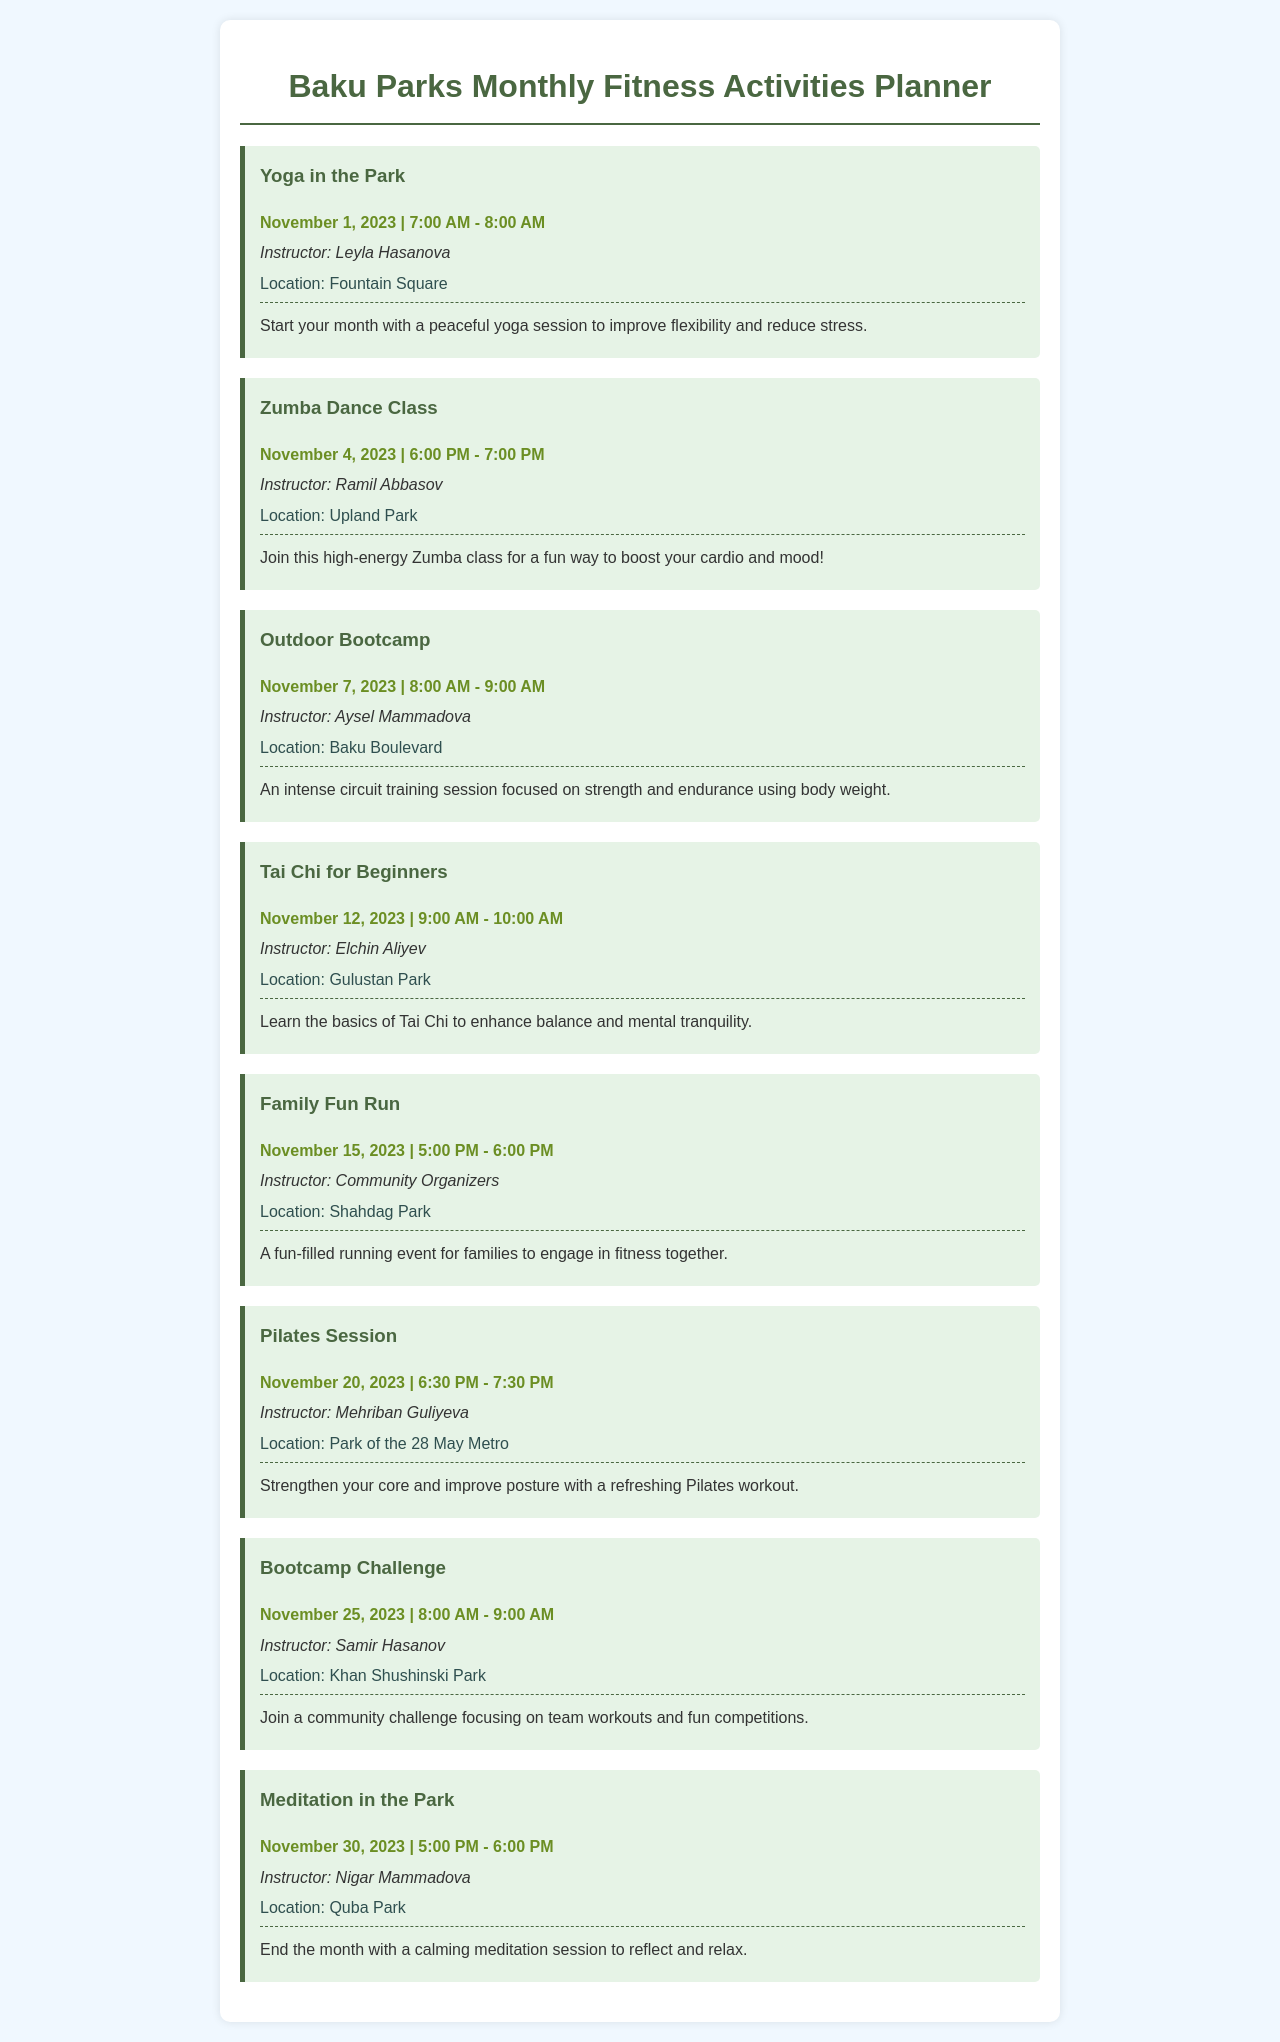What is the first fitness activity listed? The first activity listed in the planner is "Yoga in the Park."
Answer: Yoga in the Park Who is the instructor for the Zumba Dance Class? The Zumba Dance Class instructor is Ramil Abbasov.
Answer: Ramil Abbasov When does the Outdoor Bootcamp start? The Outdoor Bootcamp starts on November 7, 2023, at 8:00 AM.
Answer: November 7, 2023 What is the location for the Family Fun Run? The Family Fun Run takes place at Shahdag Park.
Answer: Shahdag Park How many fitness activities are scheduled for November? There are 8 fitness activities scheduled for November.
Answer: 8 Which class focuses on balance and mental tranquility? The class that focuses on balance and mental tranquility is Tai Chi for Beginners.
Answer: Tai Chi for Beginners What time does the Meditation in the Park start? The Meditation in the Park starts at 5:00 PM.
Answer: 5:00 PM Who are the instructors for the activities during the last week of November? The instructors for the last week are Samir Hasanov and Nigar Mammadova.
Answer: Samir Hasanov, Nigar Mammadova 